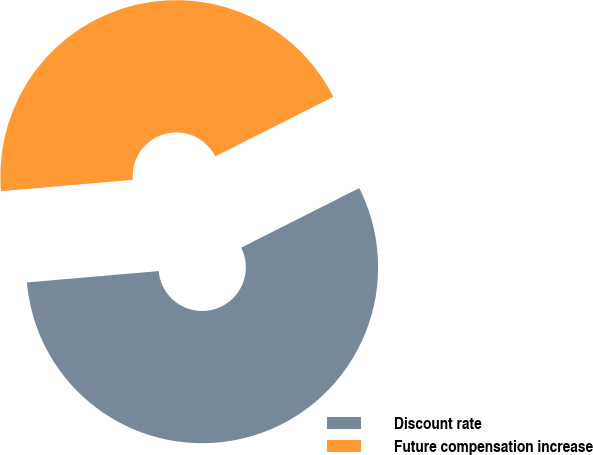Convert chart. <chart><loc_0><loc_0><loc_500><loc_500><pie_chart><fcel>Discount rate<fcel>Future compensation increase<nl><fcel>56.06%<fcel>43.94%<nl></chart> 